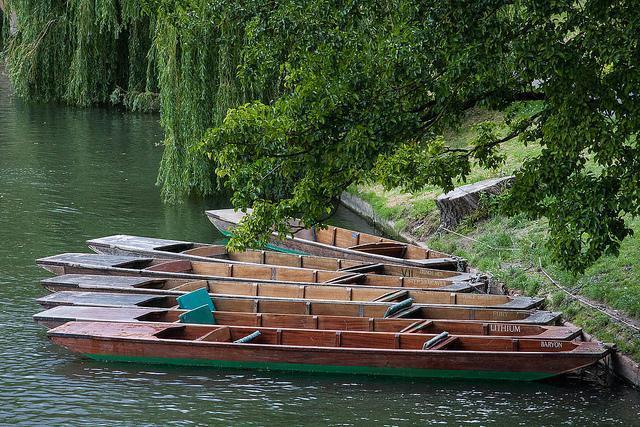How many bottles are visible?
Give a very brief answer. 0. How many boats are visible?
Give a very brief answer. 7. How many adult birds are there?
Give a very brief answer. 0. 